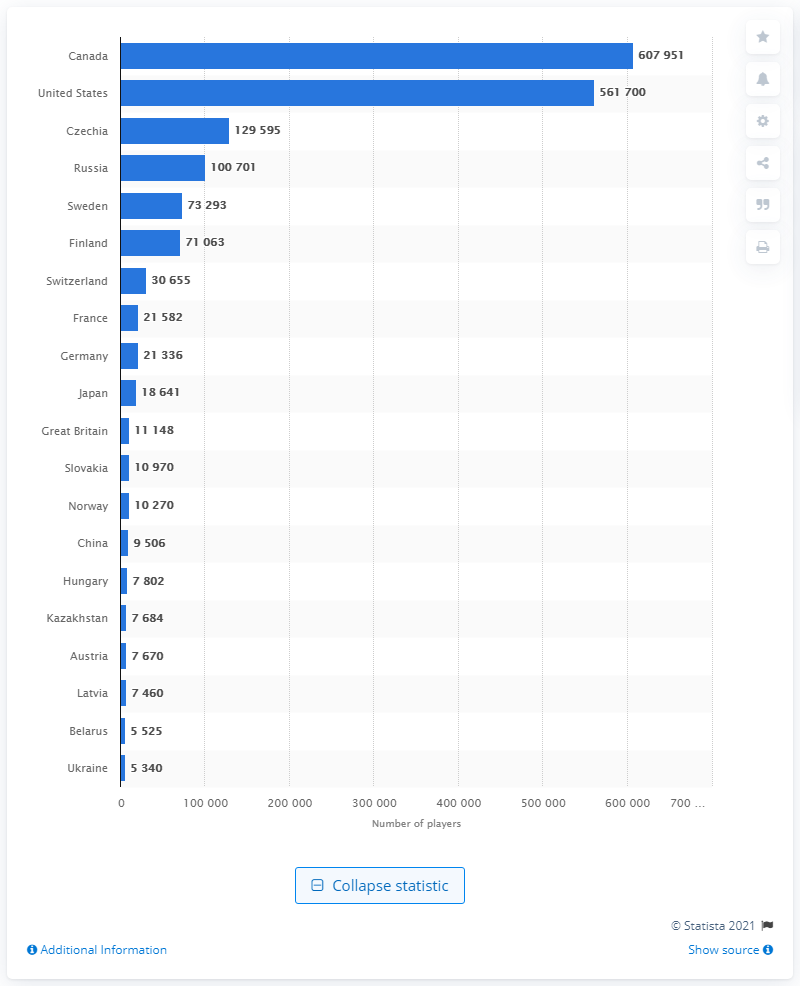Give some essential details in this illustration. Canada had a total of 607,951 registered ice hockey players in the 2019/2020 season. Canada had the most registered ice hockey players in the 2019/20 season, according to data. 